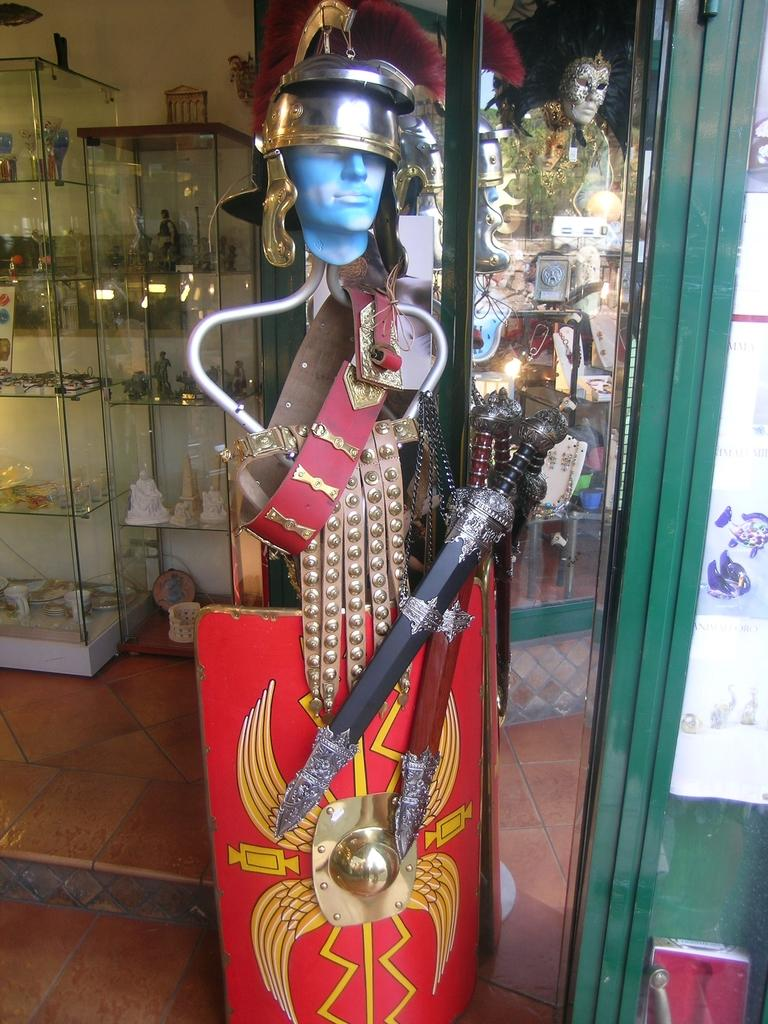What type of objects can be seen in the image? There are weapons and objects placed in the image. What type of doors are visible in the image? There are glass doors in the image. What is present in the background of the image? There is a glass shelf in the background of the image. What is placed on the glass shelf? Objects are placed on the glass shelf. What invention is being celebrated on the wall in the image? There is no wall or invention celebration present in the image. 